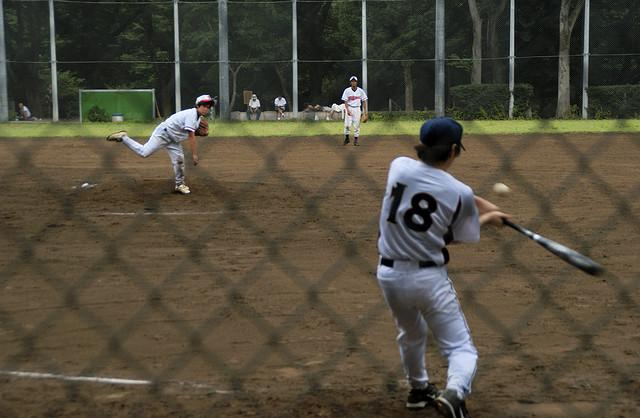Who will next cause the balls direction to change? batter 